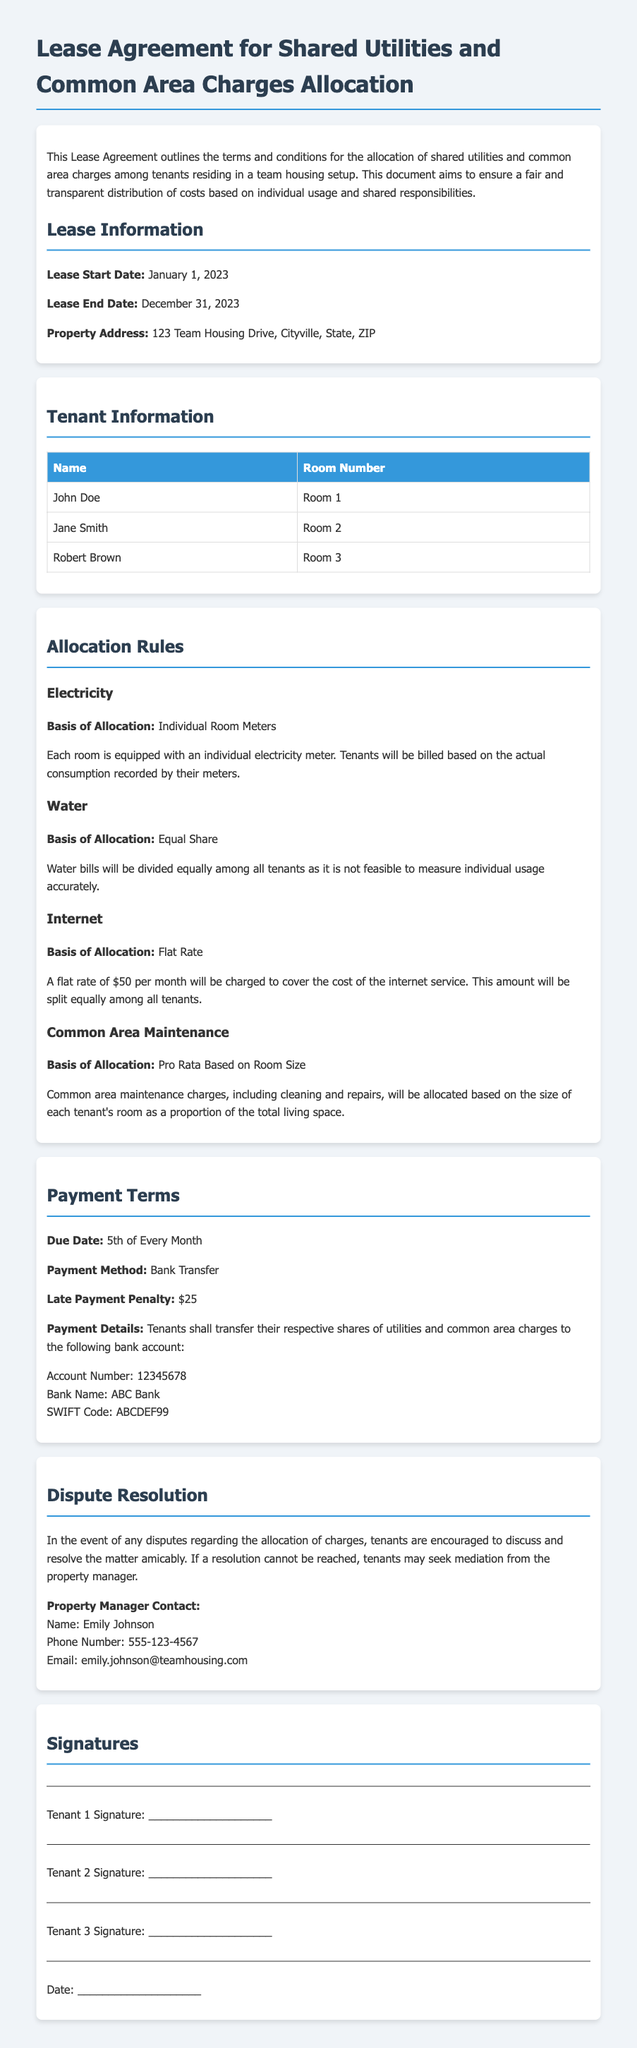what is the lease start date? The lease start date is mentioned clearly under the Lease Information section.
Answer: January 1, 2023 what is the total number of tenants listed? This information can be found in the Tenant Information section where the names of the tenants are provided.
Answer: 3 how is the water bill allocated? The allocation method for water is outlined in the Allocation Rules section.
Answer: Equal Share what is the late payment penalty? The late payment penalty is specified in the Payment Terms section of the document.
Answer: $25 who should tenants contact in case of disputes? This contact information is provided in the Dispute Resolution section of the document.
Answer: Emily Johnson what is the payment due date? The due date for payments is found in the Payment Terms section.
Answer: 5th of Every Month how is the common area maintenance charge allocated? The basis for allocation of common area maintenance charges is described in the Allocation Rules section.
Answer: Pro Rata Based on Room Size what is the monthly internet cost? The amount charged for internet service is specified in the Allocation Rules section.
Answer: $50 what payment method should be used? The acceptable payment method is detailed in the Payment Terms section.
Answer: Bank Transfer 